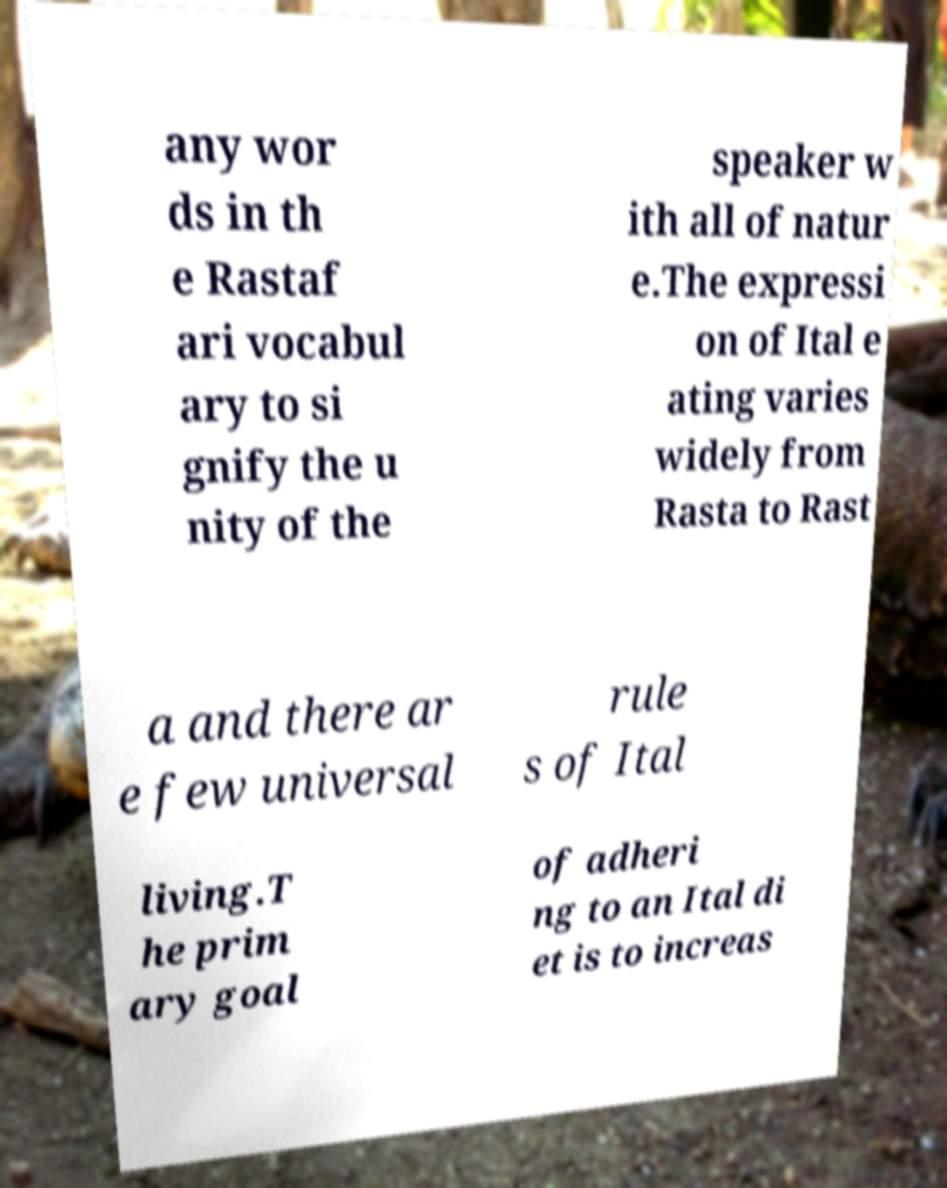For documentation purposes, I need the text within this image transcribed. Could you provide that? any wor ds in th e Rastaf ari vocabul ary to si gnify the u nity of the speaker w ith all of natur e.The expressi on of Ital e ating varies widely from Rasta to Rast a and there ar e few universal rule s of Ital living.T he prim ary goal of adheri ng to an Ital di et is to increas 